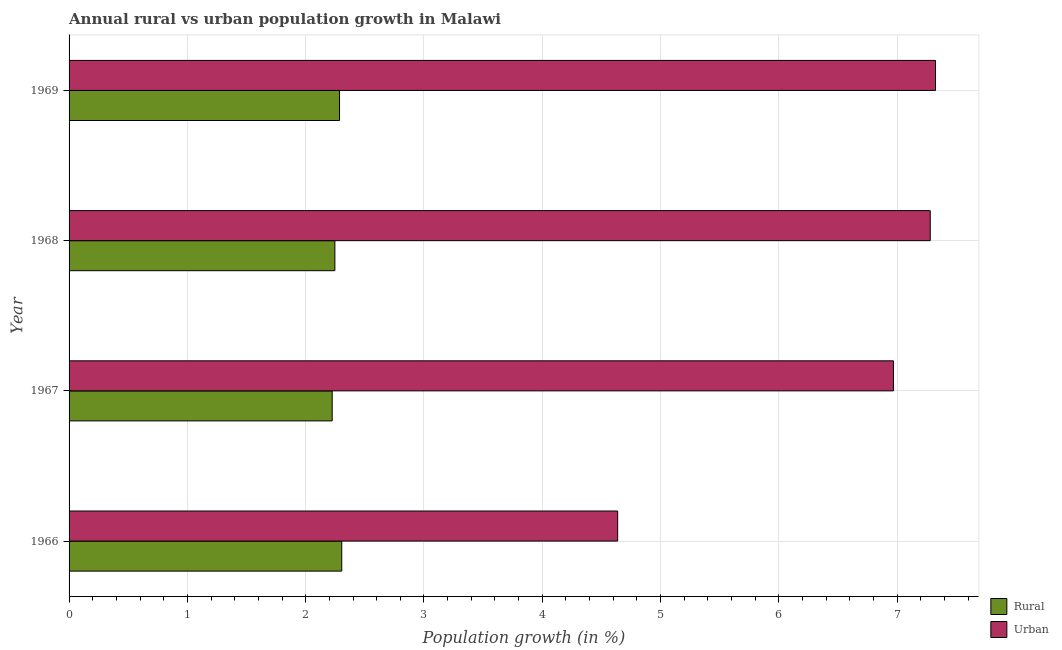Are the number of bars per tick equal to the number of legend labels?
Your answer should be compact. Yes. Are the number of bars on each tick of the Y-axis equal?
Ensure brevity in your answer.  Yes. What is the label of the 4th group of bars from the top?
Keep it short and to the point. 1966. In how many cases, is the number of bars for a given year not equal to the number of legend labels?
Ensure brevity in your answer.  0. What is the rural population growth in 1969?
Provide a short and direct response. 2.29. Across all years, what is the maximum urban population growth?
Provide a succinct answer. 7.32. Across all years, what is the minimum urban population growth?
Make the answer very short. 4.64. In which year was the urban population growth maximum?
Provide a succinct answer. 1969. In which year was the rural population growth minimum?
Provide a succinct answer. 1967. What is the total urban population growth in the graph?
Offer a terse response. 26.21. What is the difference between the rural population growth in 1966 and that in 1967?
Offer a terse response. 0.08. What is the difference between the rural population growth in 1967 and the urban population growth in 1968?
Keep it short and to the point. -5.06. What is the average urban population growth per year?
Provide a short and direct response. 6.55. In the year 1969, what is the difference between the urban population growth and rural population growth?
Your answer should be very brief. 5.04. What is the ratio of the urban population growth in 1966 to that in 1968?
Give a very brief answer. 0.64. What is the difference between the highest and the second highest urban population growth?
Your response must be concise. 0.04. What is the difference between the highest and the lowest rural population growth?
Your answer should be compact. 0.08. Is the sum of the urban population growth in 1967 and 1968 greater than the maximum rural population growth across all years?
Keep it short and to the point. Yes. What does the 1st bar from the top in 1969 represents?
Make the answer very short. Urban . What does the 1st bar from the bottom in 1969 represents?
Offer a very short reply. Rural. What is the difference between two consecutive major ticks on the X-axis?
Ensure brevity in your answer.  1. Are the values on the major ticks of X-axis written in scientific E-notation?
Provide a succinct answer. No. Does the graph contain grids?
Offer a terse response. Yes. How many legend labels are there?
Make the answer very short. 2. What is the title of the graph?
Keep it short and to the point. Annual rural vs urban population growth in Malawi. Does "Current US$" appear as one of the legend labels in the graph?
Offer a terse response. No. What is the label or title of the X-axis?
Your answer should be very brief. Population growth (in %). What is the label or title of the Y-axis?
Your response must be concise. Year. What is the Population growth (in %) in Rural in 1966?
Offer a very short reply. 2.31. What is the Population growth (in %) of Urban  in 1966?
Keep it short and to the point. 4.64. What is the Population growth (in %) of Rural in 1967?
Make the answer very short. 2.22. What is the Population growth (in %) in Urban  in 1967?
Make the answer very short. 6.97. What is the Population growth (in %) in Rural in 1968?
Ensure brevity in your answer.  2.25. What is the Population growth (in %) in Urban  in 1968?
Make the answer very short. 7.28. What is the Population growth (in %) in Rural in 1969?
Give a very brief answer. 2.29. What is the Population growth (in %) of Urban  in 1969?
Provide a short and direct response. 7.32. Across all years, what is the maximum Population growth (in %) of Rural?
Your response must be concise. 2.31. Across all years, what is the maximum Population growth (in %) of Urban ?
Provide a succinct answer. 7.32. Across all years, what is the minimum Population growth (in %) in Rural?
Make the answer very short. 2.22. Across all years, what is the minimum Population growth (in %) of Urban ?
Provide a short and direct response. 4.64. What is the total Population growth (in %) in Rural in the graph?
Your answer should be compact. 9.06. What is the total Population growth (in %) of Urban  in the graph?
Offer a very short reply. 26.21. What is the difference between the Population growth (in %) in Rural in 1966 and that in 1967?
Provide a succinct answer. 0.08. What is the difference between the Population growth (in %) in Urban  in 1966 and that in 1967?
Your answer should be compact. -2.33. What is the difference between the Population growth (in %) in Rural in 1966 and that in 1968?
Provide a short and direct response. 0.06. What is the difference between the Population growth (in %) in Urban  in 1966 and that in 1968?
Your response must be concise. -2.64. What is the difference between the Population growth (in %) in Rural in 1966 and that in 1969?
Provide a succinct answer. 0.02. What is the difference between the Population growth (in %) of Urban  in 1966 and that in 1969?
Provide a short and direct response. -2.69. What is the difference between the Population growth (in %) of Rural in 1967 and that in 1968?
Make the answer very short. -0.02. What is the difference between the Population growth (in %) of Urban  in 1967 and that in 1968?
Offer a very short reply. -0.31. What is the difference between the Population growth (in %) of Rural in 1967 and that in 1969?
Ensure brevity in your answer.  -0.06. What is the difference between the Population growth (in %) of Urban  in 1967 and that in 1969?
Offer a terse response. -0.36. What is the difference between the Population growth (in %) of Rural in 1968 and that in 1969?
Provide a succinct answer. -0.04. What is the difference between the Population growth (in %) in Urban  in 1968 and that in 1969?
Give a very brief answer. -0.04. What is the difference between the Population growth (in %) in Rural in 1966 and the Population growth (in %) in Urban  in 1967?
Give a very brief answer. -4.66. What is the difference between the Population growth (in %) of Rural in 1966 and the Population growth (in %) of Urban  in 1968?
Make the answer very short. -4.97. What is the difference between the Population growth (in %) in Rural in 1966 and the Population growth (in %) in Urban  in 1969?
Make the answer very short. -5.02. What is the difference between the Population growth (in %) in Rural in 1967 and the Population growth (in %) in Urban  in 1968?
Your response must be concise. -5.06. What is the difference between the Population growth (in %) of Rural in 1967 and the Population growth (in %) of Urban  in 1969?
Offer a very short reply. -5.1. What is the difference between the Population growth (in %) in Rural in 1968 and the Population growth (in %) in Urban  in 1969?
Provide a succinct answer. -5.08. What is the average Population growth (in %) of Rural per year?
Make the answer very short. 2.27. What is the average Population growth (in %) of Urban  per year?
Provide a succinct answer. 6.55. In the year 1966, what is the difference between the Population growth (in %) of Rural and Population growth (in %) of Urban ?
Your answer should be compact. -2.33. In the year 1967, what is the difference between the Population growth (in %) of Rural and Population growth (in %) of Urban ?
Offer a very short reply. -4.74. In the year 1968, what is the difference between the Population growth (in %) in Rural and Population growth (in %) in Urban ?
Your answer should be compact. -5.03. In the year 1969, what is the difference between the Population growth (in %) of Rural and Population growth (in %) of Urban ?
Provide a short and direct response. -5.04. What is the ratio of the Population growth (in %) in Rural in 1966 to that in 1967?
Provide a succinct answer. 1.04. What is the ratio of the Population growth (in %) of Urban  in 1966 to that in 1967?
Offer a very short reply. 0.67. What is the ratio of the Population growth (in %) of Rural in 1966 to that in 1968?
Offer a terse response. 1.03. What is the ratio of the Population growth (in %) of Urban  in 1966 to that in 1968?
Offer a terse response. 0.64. What is the ratio of the Population growth (in %) in Rural in 1966 to that in 1969?
Provide a short and direct response. 1.01. What is the ratio of the Population growth (in %) in Urban  in 1966 to that in 1969?
Offer a terse response. 0.63. What is the ratio of the Population growth (in %) in Rural in 1967 to that in 1968?
Keep it short and to the point. 0.99. What is the ratio of the Population growth (in %) of Urban  in 1967 to that in 1968?
Offer a terse response. 0.96. What is the ratio of the Population growth (in %) in Rural in 1967 to that in 1969?
Your answer should be compact. 0.97. What is the ratio of the Population growth (in %) in Urban  in 1967 to that in 1969?
Provide a succinct answer. 0.95. What is the ratio of the Population growth (in %) in Rural in 1968 to that in 1969?
Give a very brief answer. 0.98. What is the ratio of the Population growth (in %) of Urban  in 1968 to that in 1969?
Keep it short and to the point. 0.99. What is the difference between the highest and the second highest Population growth (in %) in Rural?
Your answer should be very brief. 0.02. What is the difference between the highest and the second highest Population growth (in %) of Urban ?
Offer a very short reply. 0.04. What is the difference between the highest and the lowest Population growth (in %) of Rural?
Keep it short and to the point. 0.08. What is the difference between the highest and the lowest Population growth (in %) in Urban ?
Offer a terse response. 2.69. 